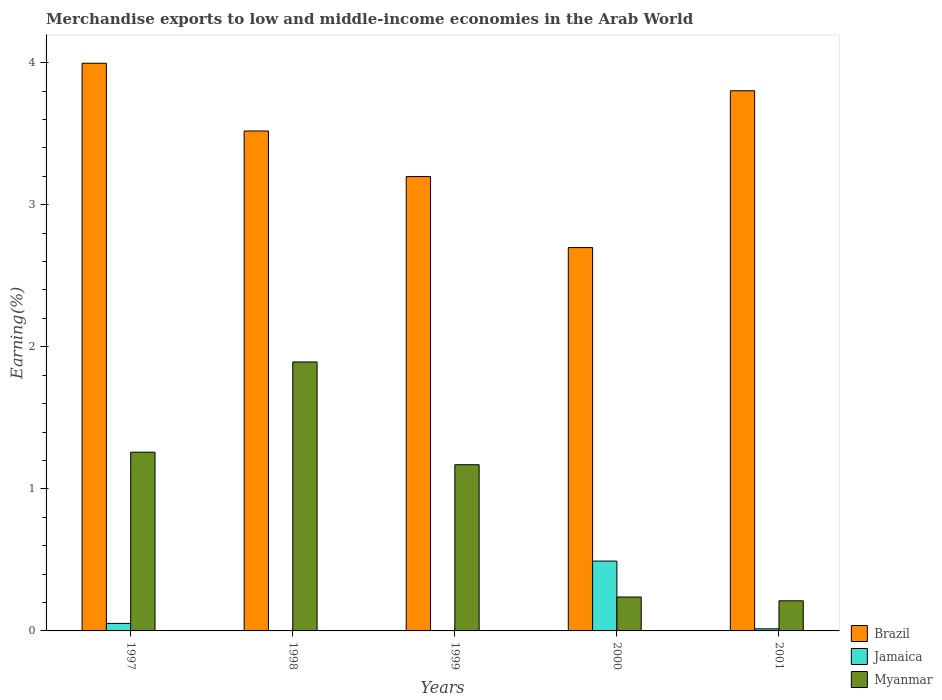How many different coloured bars are there?
Your response must be concise. 3. In how many cases, is the number of bars for a given year not equal to the number of legend labels?
Provide a succinct answer. 0. What is the percentage of amount earned from merchandise exports in Jamaica in 1998?
Your response must be concise. 0. Across all years, what is the maximum percentage of amount earned from merchandise exports in Brazil?
Ensure brevity in your answer.  4. Across all years, what is the minimum percentage of amount earned from merchandise exports in Myanmar?
Offer a terse response. 0.21. In which year was the percentage of amount earned from merchandise exports in Jamaica maximum?
Offer a very short reply. 2000. In which year was the percentage of amount earned from merchandise exports in Brazil minimum?
Make the answer very short. 2000. What is the total percentage of amount earned from merchandise exports in Brazil in the graph?
Your answer should be very brief. 17.21. What is the difference between the percentage of amount earned from merchandise exports in Brazil in 1998 and that in 2000?
Your answer should be compact. 0.82. What is the difference between the percentage of amount earned from merchandise exports in Jamaica in 2000 and the percentage of amount earned from merchandise exports in Myanmar in 1999?
Ensure brevity in your answer.  -0.68. What is the average percentage of amount earned from merchandise exports in Jamaica per year?
Your response must be concise. 0.11. In the year 1998, what is the difference between the percentage of amount earned from merchandise exports in Myanmar and percentage of amount earned from merchandise exports in Brazil?
Offer a very short reply. -1.63. In how many years, is the percentage of amount earned from merchandise exports in Jamaica greater than 1.2 %?
Make the answer very short. 0. What is the ratio of the percentage of amount earned from merchandise exports in Brazil in 1998 to that in 1999?
Your answer should be very brief. 1.1. Is the difference between the percentage of amount earned from merchandise exports in Myanmar in 1997 and 2000 greater than the difference between the percentage of amount earned from merchandise exports in Brazil in 1997 and 2000?
Offer a very short reply. No. What is the difference between the highest and the second highest percentage of amount earned from merchandise exports in Myanmar?
Keep it short and to the point. 0.64. What is the difference between the highest and the lowest percentage of amount earned from merchandise exports in Brazil?
Provide a short and direct response. 1.3. In how many years, is the percentage of amount earned from merchandise exports in Jamaica greater than the average percentage of amount earned from merchandise exports in Jamaica taken over all years?
Ensure brevity in your answer.  1. What does the 3rd bar from the left in 1998 represents?
Your answer should be very brief. Myanmar. How many bars are there?
Offer a terse response. 15. What is the difference between two consecutive major ticks on the Y-axis?
Give a very brief answer. 1. Does the graph contain any zero values?
Offer a terse response. No. How many legend labels are there?
Offer a very short reply. 3. What is the title of the graph?
Your response must be concise. Merchandise exports to low and middle-income economies in the Arab World. Does "Cuba" appear as one of the legend labels in the graph?
Your answer should be very brief. No. What is the label or title of the X-axis?
Provide a succinct answer. Years. What is the label or title of the Y-axis?
Your answer should be compact. Earning(%). What is the Earning(%) in Brazil in 1997?
Your response must be concise. 4. What is the Earning(%) of Jamaica in 1997?
Keep it short and to the point. 0.05. What is the Earning(%) of Myanmar in 1997?
Give a very brief answer. 1.26. What is the Earning(%) in Brazil in 1998?
Make the answer very short. 3.52. What is the Earning(%) in Jamaica in 1998?
Your response must be concise. 0. What is the Earning(%) of Myanmar in 1998?
Give a very brief answer. 1.89. What is the Earning(%) of Brazil in 1999?
Give a very brief answer. 3.2. What is the Earning(%) in Jamaica in 1999?
Offer a terse response. 0. What is the Earning(%) of Myanmar in 1999?
Offer a very short reply. 1.17. What is the Earning(%) in Brazil in 2000?
Give a very brief answer. 2.7. What is the Earning(%) in Jamaica in 2000?
Provide a succinct answer. 0.49. What is the Earning(%) of Myanmar in 2000?
Offer a very short reply. 0.24. What is the Earning(%) in Brazil in 2001?
Provide a succinct answer. 3.8. What is the Earning(%) of Jamaica in 2001?
Provide a succinct answer. 0.01. What is the Earning(%) of Myanmar in 2001?
Your answer should be very brief. 0.21. Across all years, what is the maximum Earning(%) in Brazil?
Provide a short and direct response. 4. Across all years, what is the maximum Earning(%) of Jamaica?
Your response must be concise. 0.49. Across all years, what is the maximum Earning(%) of Myanmar?
Offer a very short reply. 1.89. Across all years, what is the minimum Earning(%) of Brazil?
Your answer should be very brief. 2.7. Across all years, what is the minimum Earning(%) in Jamaica?
Give a very brief answer. 0. Across all years, what is the minimum Earning(%) in Myanmar?
Your response must be concise. 0.21. What is the total Earning(%) of Brazil in the graph?
Give a very brief answer. 17.21. What is the total Earning(%) in Jamaica in the graph?
Provide a succinct answer. 0.56. What is the total Earning(%) of Myanmar in the graph?
Give a very brief answer. 4.77. What is the difference between the Earning(%) of Brazil in 1997 and that in 1998?
Keep it short and to the point. 0.48. What is the difference between the Earning(%) in Jamaica in 1997 and that in 1998?
Offer a very short reply. 0.05. What is the difference between the Earning(%) in Myanmar in 1997 and that in 1998?
Provide a succinct answer. -0.64. What is the difference between the Earning(%) in Brazil in 1997 and that in 1999?
Offer a very short reply. 0.8. What is the difference between the Earning(%) in Jamaica in 1997 and that in 1999?
Ensure brevity in your answer.  0.05. What is the difference between the Earning(%) of Myanmar in 1997 and that in 1999?
Offer a terse response. 0.09. What is the difference between the Earning(%) in Brazil in 1997 and that in 2000?
Give a very brief answer. 1.3. What is the difference between the Earning(%) of Jamaica in 1997 and that in 2000?
Ensure brevity in your answer.  -0.44. What is the difference between the Earning(%) in Myanmar in 1997 and that in 2000?
Your answer should be compact. 1.02. What is the difference between the Earning(%) in Brazil in 1997 and that in 2001?
Make the answer very short. 0.19. What is the difference between the Earning(%) in Jamaica in 1997 and that in 2001?
Provide a succinct answer. 0.04. What is the difference between the Earning(%) of Myanmar in 1997 and that in 2001?
Offer a terse response. 1.05. What is the difference between the Earning(%) of Brazil in 1998 and that in 1999?
Your answer should be very brief. 0.32. What is the difference between the Earning(%) of Jamaica in 1998 and that in 1999?
Your response must be concise. -0. What is the difference between the Earning(%) of Myanmar in 1998 and that in 1999?
Your answer should be very brief. 0.72. What is the difference between the Earning(%) in Brazil in 1998 and that in 2000?
Your answer should be compact. 0.82. What is the difference between the Earning(%) of Jamaica in 1998 and that in 2000?
Make the answer very short. -0.49. What is the difference between the Earning(%) of Myanmar in 1998 and that in 2000?
Your answer should be compact. 1.65. What is the difference between the Earning(%) in Brazil in 1998 and that in 2001?
Provide a succinct answer. -0.28. What is the difference between the Earning(%) of Jamaica in 1998 and that in 2001?
Give a very brief answer. -0.01. What is the difference between the Earning(%) of Myanmar in 1998 and that in 2001?
Your answer should be compact. 1.68. What is the difference between the Earning(%) in Brazil in 1999 and that in 2000?
Provide a succinct answer. 0.5. What is the difference between the Earning(%) in Jamaica in 1999 and that in 2000?
Your answer should be very brief. -0.49. What is the difference between the Earning(%) in Myanmar in 1999 and that in 2000?
Provide a succinct answer. 0.93. What is the difference between the Earning(%) in Brazil in 1999 and that in 2001?
Your answer should be very brief. -0.6. What is the difference between the Earning(%) in Jamaica in 1999 and that in 2001?
Give a very brief answer. -0.01. What is the difference between the Earning(%) in Myanmar in 1999 and that in 2001?
Provide a short and direct response. 0.96. What is the difference between the Earning(%) in Brazil in 2000 and that in 2001?
Ensure brevity in your answer.  -1.1. What is the difference between the Earning(%) in Jamaica in 2000 and that in 2001?
Offer a very short reply. 0.48. What is the difference between the Earning(%) in Myanmar in 2000 and that in 2001?
Keep it short and to the point. 0.03. What is the difference between the Earning(%) of Brazil in 1997 and the Earning(%) of Jamaica in 1998?
Give a very brief answer. 4. What is the difference between the Earning(%) of Brazil in 1997 and the Earning(%) of Myanmar in 1998?
Make the answer very short. 2.1. What is the difference between the Earning(%) of Jamaica in 1997 and the Earning(%) of Myanmar in 1998?
Offer a terse response. -1.84. What is the difference between the Earning(%) of Brazil in 1997 and the Earning(%) of Jamaica in 1999?
Make the answer very short. 3.99. What is the difference between the Earning(%) of Brazil in 1997 and the Earning(%) of Myanmar in 1999?
Your answer should be very brief. 2.83. What is the difference between the Earning(%) in Jamaica in 1997 and the Earning(%) in Myanmar in 1999?
Offer a terse response. -1.12. What is the difference between the Earning(%) in Brazil in 1997 and the Earning(%) in Jamaica in 2000?
Keep it short and to the point. 3.5. What is the difference between the Earning(%) of Brazil in 1997 and the Earning(%) of Myanmar in 2000?
Provide a short and direct response. 3.76. What is the difference between the Earning(%) of Jamaica in 1997 and the Earning(%) of Myanmar in 2000?
Offer a terse response. -0.19. What is the difference between the Earning(%) of Brazil in 1997 and the Earning(%) of Jamaica in 2001?
Keep it short and to the point. 3.98. What is the difference between the Earning(%) in Brazil in 1997 and the Earning(%) in Myanmar in 2001?
Offer a very short reply. 3.78. What is the difference between the Earning(%) in Jamaica in 1997 and the Earning(%) in Myanmar in 2001?
Offer a terse response. -0.16. What is the difference between the Earning(%) in Brazil in 1998 and the Earning(%) in Jamaica in 1999?
Your answer should be very brief. 3.52. What is the difference between the Earning(%) in Brazil in 1998 and the Earning(%) in Myanmar in 1999?
Your answer should be compact. 2.35. What is the difference between the Earning(%) of Jamaica in 1998 and the Earning(%) of Myanmar in 1999?
Keep it short and to the point. -1.17. What is the difference between the Earning(%) in Brazil in 1998 and the Earning(%) in Jamaica in 2000?
Your answer should be compact. 3.03. What is the difference between the Earning(%) in Brazil in 1998 and the Earning(%) in Myanmar in 2000?
Keep it short and to the point. 3.28. What is the difference between the Earning(%) in Jamaica in 1998 and the Earning(%) in Myanmar in 2000?
Offer a terse response. -0.24. What is the difference between the Earning(%) in Brazil in 1998 and the Earning(%) in Jamaica in 2001?
Your answer should be very brief. 3.5. What is the difference between the Earning(%) in Brazil in 1998 and the Earning(%) in Myanmar in 2001?
Ensure brevity in your answer.  3.31. What is the difference between the Earning(%) in Jamaica in 1998 and the Earning(%) in Myanmar in 2001?
Ensure brevity in your answer.  -0.21. What is the difference between the Earning(%) of Brazil in 1999 and the Earning(%) of Jamaica in 2000?
Provide a short and direct response. 2.71. What is the difference between the Earning(%) of Brazil in 1999 and the Earning(%) of Myanmar in 2000?
Offer a terse response. 2.96. What is the difference between the Earning(%) of Jamaica in 1999 and the Earning(%) of Myanmar in 2000?
Ensure brevity in your answer.  -0.24. What is the difference between the Earning(%) in Brazil in 1999 and the Earning(%) in Jamaica in 2001?
Make the answer very short. 3.18. What is the difference between the Earning(%) of Brazil in 1999 and the Earning(%) of Myanmar in 2001?
Provide a succinct answer. 2.99. What is the difference between the Earning(%) of Jamaica in 1999 and the Earning(%) of Myanmar in 2001?
Offer a very short reply. -0.21. What is the difference between the Earning(%) of Brazil in 2000 and the Earning(%) of Jamaica in 2001?
Provide a short and direct response. 2.68. What is the difference between the Earning(%) of Brazil in 2000 and the Earning(%) of Myanmar in 2001?
Make the answer very short. 2.49. What is the difference between the Earning(%) in Jamaica in 2000 and the Earning(%) in Myanmar in 2001?
Offer a terse response. 0.28. What is the average Earning(%) in Brazil per year?
Provide a succinct answer. 3.44. What is the average Earning(%) of Jamaica per year?
Offer a very short reply. 0.11. What is the average Earning(%) of Myanmar per year?
Your answer should be compact. 0.95. In the year 1997, what is the difference between the Earning(%) in Brazil and Earning(%) in Jamaica?
Keep it short and to the point. 3.94. In the year 1997, what is the difference between the Earning(%) in Brazil and Earning(%) in Myanmar?
Your answer should be compact. 2.74. In the year 1997, what is the difference between the Earning(%) in Jamaica and Earning(%) in Myanmar?
Your answer should be very brief. -1.21. In the year 1998, what is the difference between the Earning(%) in Brazil and Earning(%) in Jamaica?
Give a very brief answer. 3.52. In the year 1998, what is the difference between the Earning(%) in Brazil and Earning(%) in Myanmar?
Give a very brief answer. 1.63. In the year 1998, what is the difference between the Earning(%) of Jamaica and Earning(%) of Myanmar?
Your response must be concise. -1.89. In the year 1999, what is the difference between the Earning(%) of Brazil and Earning(%) of Jamaica?
Your answer should be very brief. 3.2. In the year 1999, what is the difference between the Earning(%) in Brazil and Earning(%) in Myanmar?
Provide a short and direct response. 2.03. In the year 1999, what is the difference between the Earning(%) in Jamaica and Earning(%) in Myanmar?
Keep it short and to the point. -1.17. In the year 2000, what is the difference between the Earning(%) in Brazil and Earning(%) in Jamaica?
Keep it short and to the point. 2.21. In the year 2000, what is the difference between the Earning(%) of Brazil and Earning(%) of Myanmar?
Your answer should be very brief. 2.46. In the year 2000, what is the difference between the Earning(%) of Jamaica and Earning(%) of Myanmar?
Offer a very short reply. 0.25. In the year 2001, what is the difference between the Earning(%) in Brazil and Earning(%) in Jamaica?
Offer a terse response. 3.79. In the year 2001, what is the difference between the Earning(%) of Brazil and Earning(%) of Myanmar?
Provide a succinct answer. 3.59. In the year 2001, what is the difference between the Earning(%) in Jamaica and Earning(%) in Myanmar?
Your response must be concise. -0.2. What is the ratio of the Earning(%) in Brazil in 1997 to that in 1998?
Give a very brief answer. 1.14. What is the ratio of the Earning(%) in Jamaica in 1997 to that in 1998?
Keep it short and to the point. 119.33. What is the ratio of the Earning(%) in Myanmar in 1997 to that in 1998?
Give a very brief answer. 0.66. What is the ratio of the Earning(%) of Brazil in 1997 to that in 1999?
Offer a very short reply. 1.25. What is the ratio of the Earning(%) of Jamaica in 1997 to that in 1999?
Make the answer very short. 28.27. What is the ratio of the Earning(%) of Myanmar in 1997 to that in 1999?
Give a very brief answer. 1.08. What is the ratio of the Earning(%) of Brazil in 1997 to that in 2000?
Ensure brevity in your answer.  1.48. What is the ratio of the Earning(%) of Jamaica in 1997 to that in 2000?
Your answer should be compact. 0.11. What is the ratio of the Earning(%) in Myanmar in 1997 to that in 2000?
Your response must be concise. 5.27. What is the ratio of the Earning(%) in Brazil in 1997 to that in 2001?
Ensure brevity in your answer.  1.05. What is the ratio of the Earning(%) in Jamaica in 1997 to that in 2001?
Your answer should be compact. 3.6. What is the ratio of the Earning(%) in Myanmar in 1997 to that in 2001?
Your answer should be very brief. 5.94. What is the ratio of the Earning(%) in Brazil in 1998 to that in 1999?
Keep it short and to the point. 1.1. What is the ratio of the Earning(%) in Jamaica in 1998 to that in 1999?
Keep it short and to the point. 0.24. What is the ratio of the Earning(%) in Myanmar in 1998 to that in 1999?
Your answer should be very brief. 1.62. What is the ratio of the Earning(%) in Brazil in 1998 to that in 2000?
Offer a very short reply. 1.3. What is the ratio of the Earning(%) of Jamaica in 1998 to that in 2000?
Your answer should be compact. 0. What is the ratio of the Earning(%) of Myanmar in 1998 to that in 2000?
Provide a succinct answer. 7.93. What is the ratio of the Earning(%) in Brazil in 1998 to that in 2001?
Give a very brief answer. 0.93. What is the ratio of the Earning(%) of Jamaica in 1998 to that in 2001?
Ensure brevity in your answer.  0.03. What is the ratio of the Earning(%) in Myanmar in 1998 to that in 2001?
Provide a short and direct response. 8.93. What is the ratio of the Earning(%) of Brazil in 1999 to that in 2000?
Give a very brief answer. 1.19. What is the ratio of the Earning(%) in Jamaica in 1999 to that in 2000?
Ensure brevity in your answer.  0. What is the ratio of the Earning(%) in Myanmar in 1999 to that in 2000?
Your answer should be very brief. 4.9. What is the ratio of the Earning(%) of Brazil in 1999 to that in 2001?
Offer a terse response. 0.84. What is the ratio of the Earning(%) in Jamaica in 1999 to that in 2001?
Offer a terse response. 0.13. What is the ratio of the Earning(%) of Myanmar in 1999 to that in 2001?
Your response must be concise. 5.52. What is the ratio of the Earning(%) of Brazil in 2000 to that in 2001?
Keep it short and to the point. 0.71. What is the ratio of the Earning(%) in Jamaica in 2000 to that in 2001?
Offer a terse response. 33.48. What is the ratio of the Earning(%) of Myanmar in 2000 to that in 2001?
Give a very brief answer. 1.13. What is the difference between the highest and the second highest Earning(%) of Brazil?
Your answer should be compact. 0.19. What is the difference between the highest and the second highest Earning(%) in Jamaica?
Keep it short and to the point. 0.44. What is the difference between the highest and the second highest Earning(%) in Myanmar?
Your answer should be very brief. 0.64. What is the difference between the highest and the lowest Earning(%) of Brazil?
Your answer should be very brief. 1.3. What is the difference between the highest and the lowest Earning(%) of Jamaica?
Your response must be concise. 0.49. What is the difference between the highest and the lowest Earning(%) in Myanmar?
Ensure brevity in your answer.  1.68. 